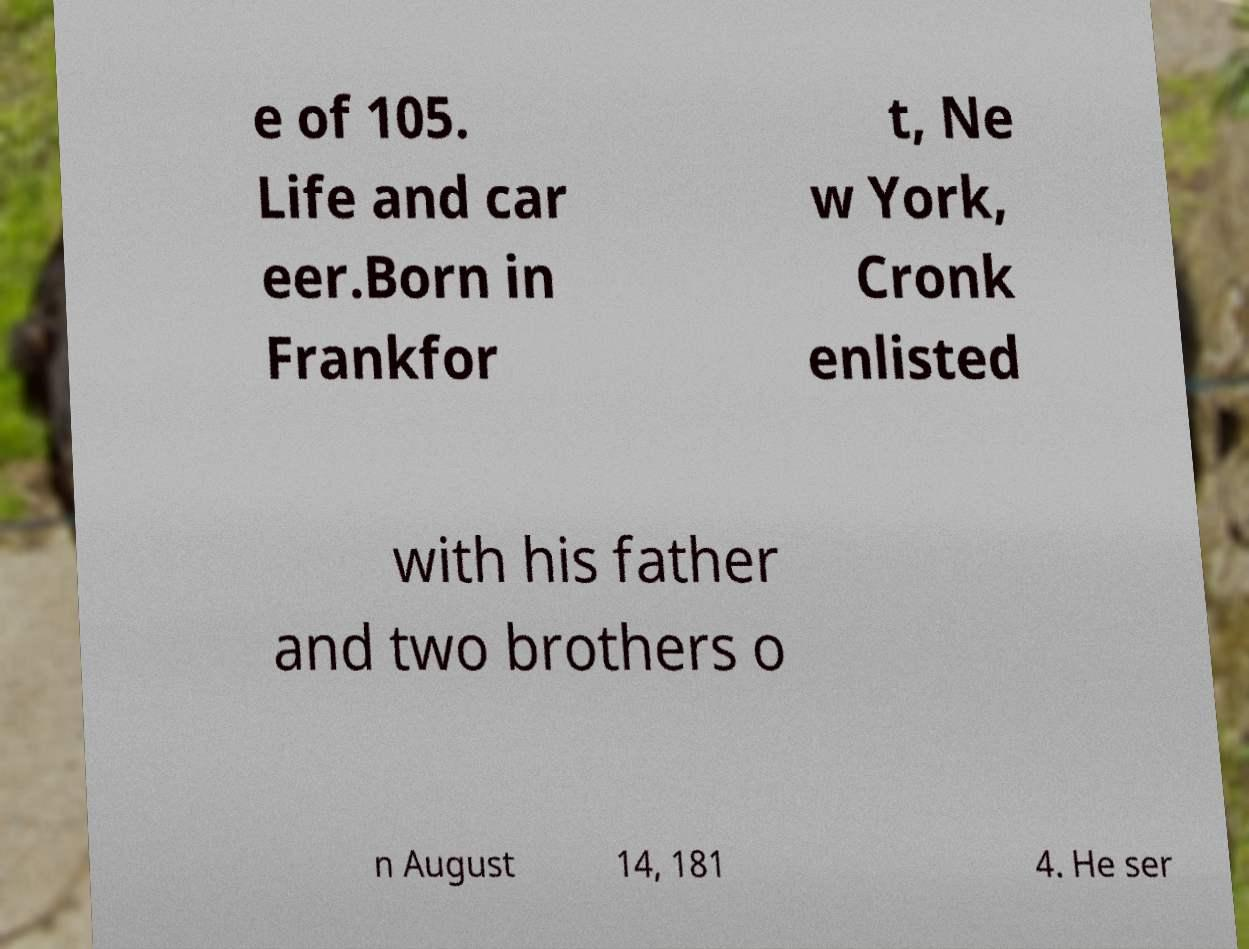Could you extract and type out the text from this image? e of 105. Life and car eer.Born in Frankfor t, Ne w York, Cronk enlisted with his father and two brothers o n August 14, 181 4. He ser 